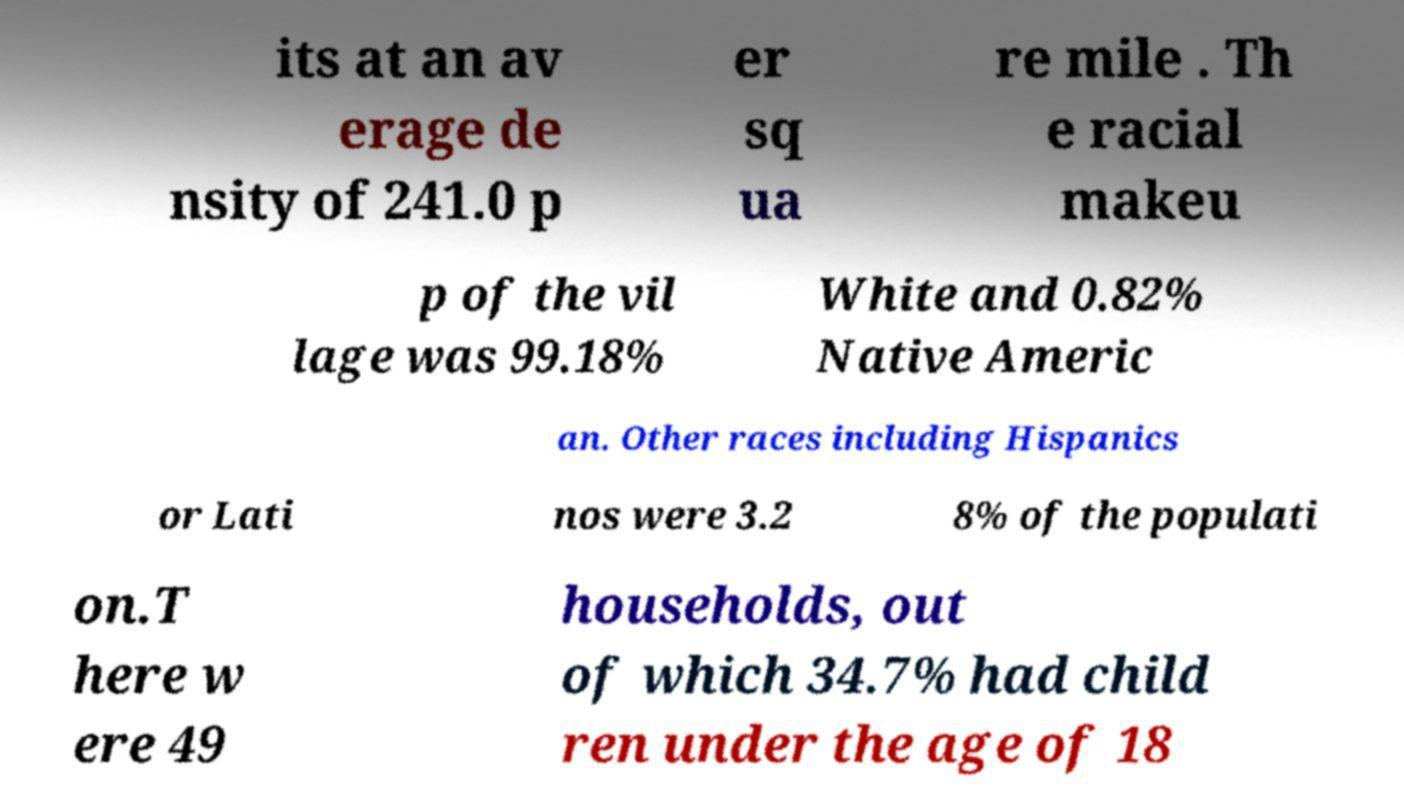I need the written content from this picture converted into text. Can you do that? its at an av erage de nsity of 241.0 p er sq ua re mile . Th e racial makeu p of the vil lage was 99.18% White and 0.82% Native Americ an. Other races including Hispanics or Lati nos were 3.2 8% of the populati on.T here w ere 49 households, out of which 34.7% had child ren under the age of 18 